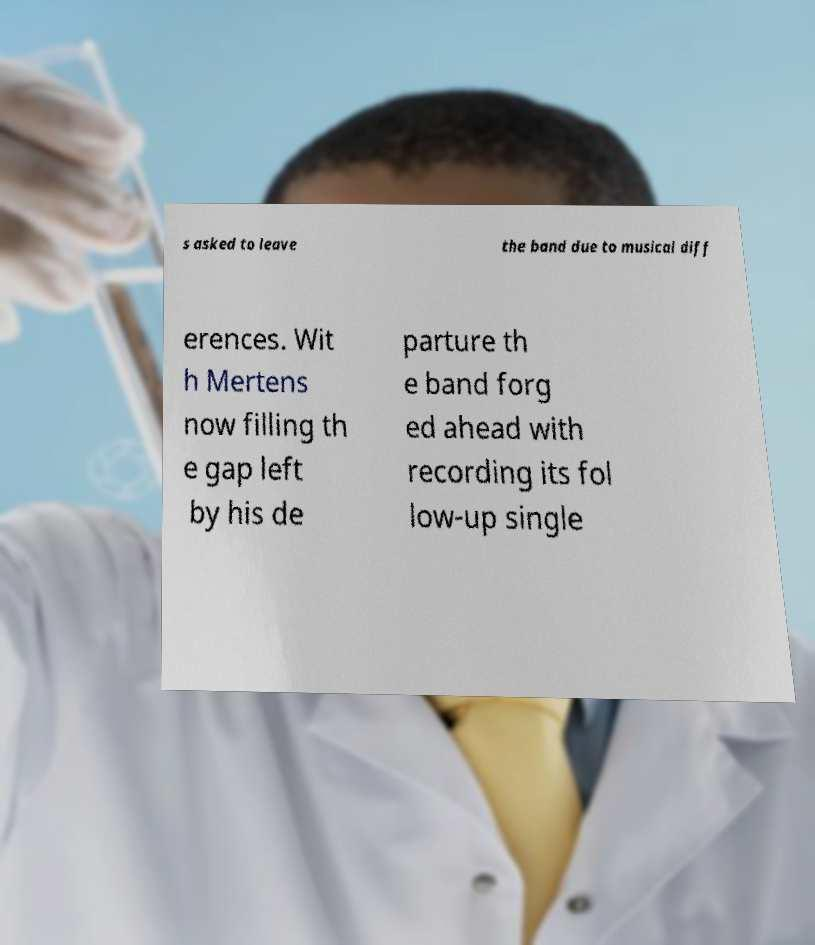Could you assist in decoding the text presented in this image and type it out clearly? s asked to leave the band due to musical diff erences. Wit h Mertens now filling th e gap left by his de parture th e band forg ed ahead with recording its fol low-up single 